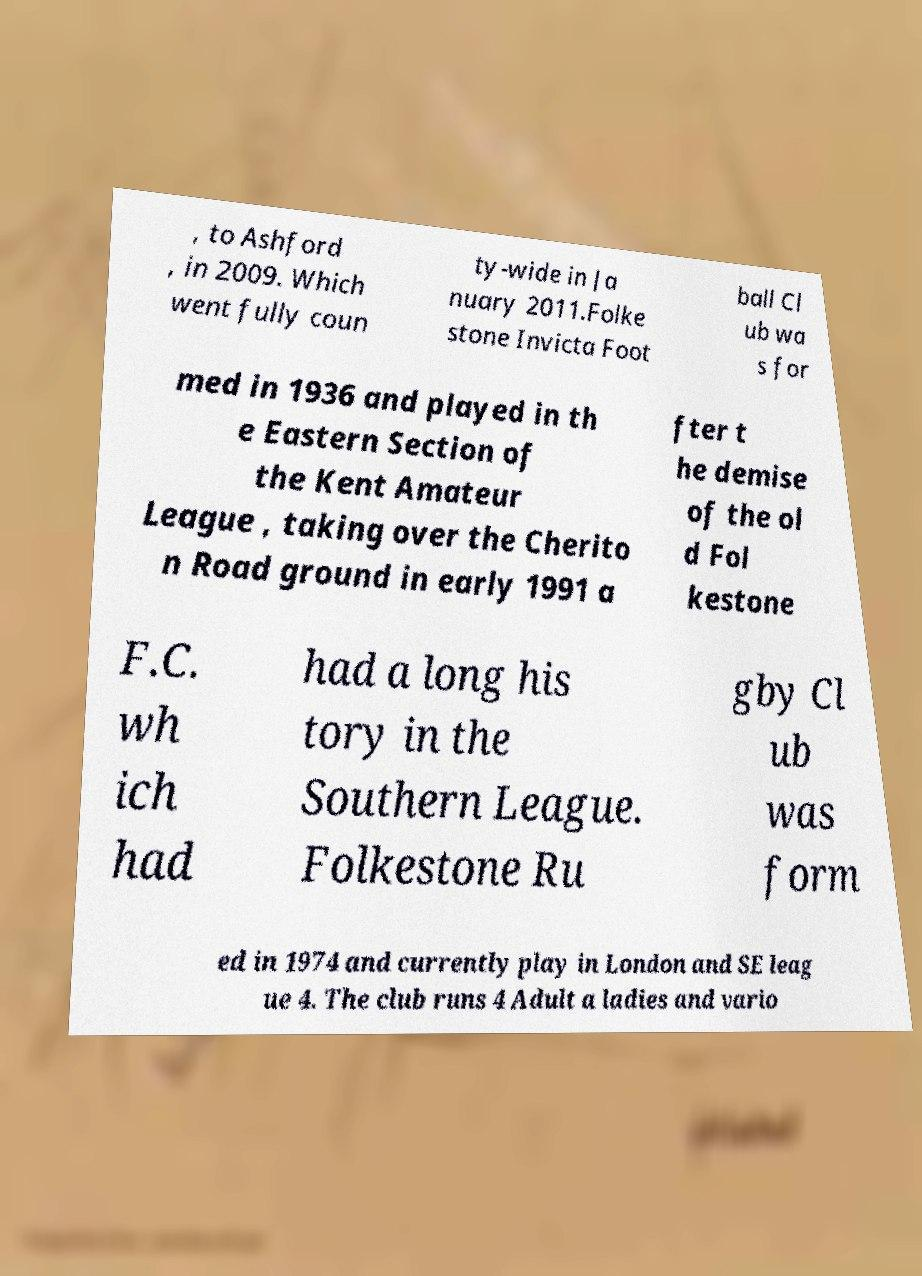Can you read and provide the text displayed in the image?This photo seems to have some interesting text. Can you extract and type it out for me? , to Ashford , in 2009. Which went fully coun ty-wide in Ja nuary 2011.Folke stone Invicta Foot ball Cl ub wa s for med in 1936 and played in th e Eastern Section of the Kent Amateur League , taking over the Cherito n Road ground in early 1991 a fter t he demise of the ol d Fol kestone F.C. wh ich had had a long his tory in the Southern League. Folkestone Ru gby Cl ub was form ed in 1974 and currently play in London and SE leag ue 4. The club runs 4 Adult a ladies and vario 